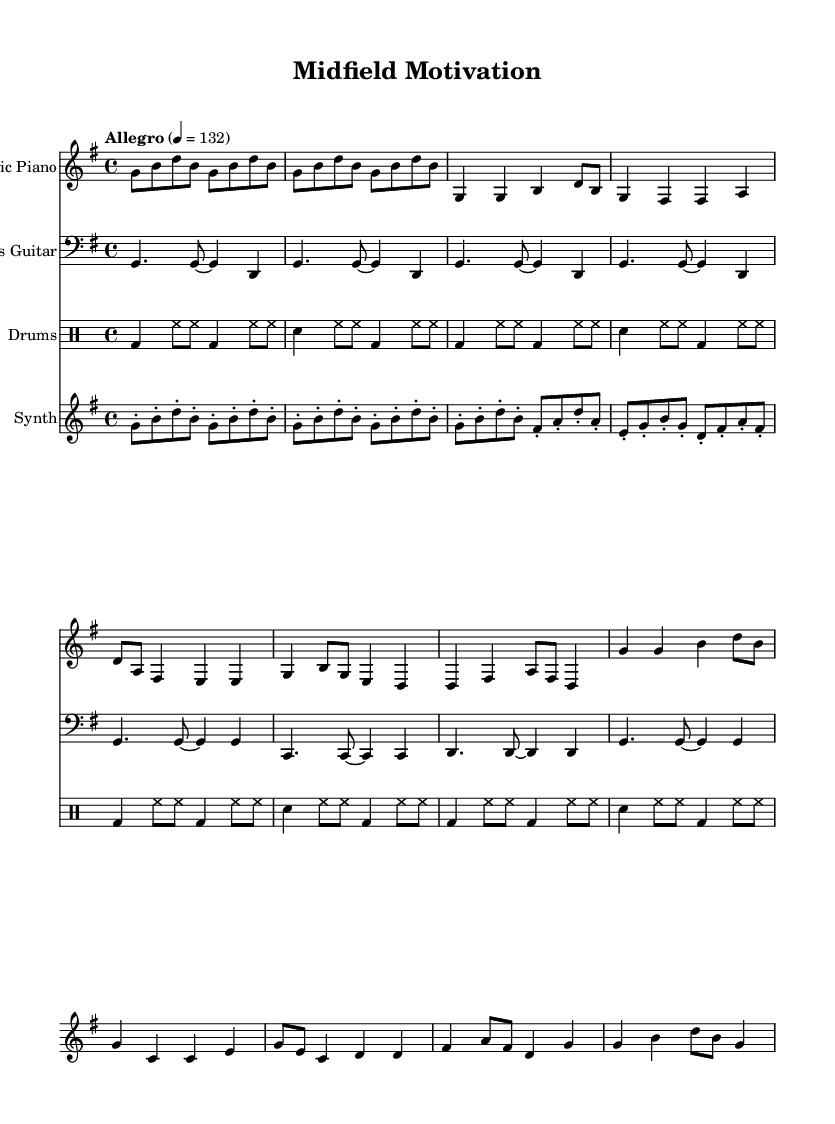What is the key signature of this music? The key signature is G major, which has one sharp (F#). This can be determined by looking at the key signature symbol at the beginning of the staff.
Answer: G major What is the time signature of this piece? The time signature is 4/4, indicating that there are four beats in each measure and the quarter note receives one beat. This can be seen at the beginning of the score next to the key signature.
Answer: 4/4 What is the tempo marking for this composition? The tempo marking is "Allegro," with a metronome marking of 132 beats per minute. This is specified above the staff, indicating a fast and lively pace for the music.
Answer: Allegro How many repeats occur in the bass guitar part during the intro and verse? The bass guitar part has four repeats of the same pattern indicated within the intro and verse sections. This can be observed from the repeat signs used in the notation.
Answer: 4 What kind of instruments are featured in this piece? The featured instruments are Electric Piano, Bass Guitar, Drums, and Synth. Each instrument is designated by the term "Staff" at the beginning of its musical section.
Answer: Electric Piano, Bass Guitar, Drums, Synth Which section has a staccato note pattern? The synth pattern contains staccato eighth notes that follow the chord progression. The staccato markings (dots) are placed above the notes in the synth staff, indicating that they should be played shorter than usual.
Answer: Synth During which part does the chorus occur? The chorus occurs after the verse section, and it can be identified by the distinct melodic line and structure that stands out from the verse while being marked in the notation.
Answer: Chorus 